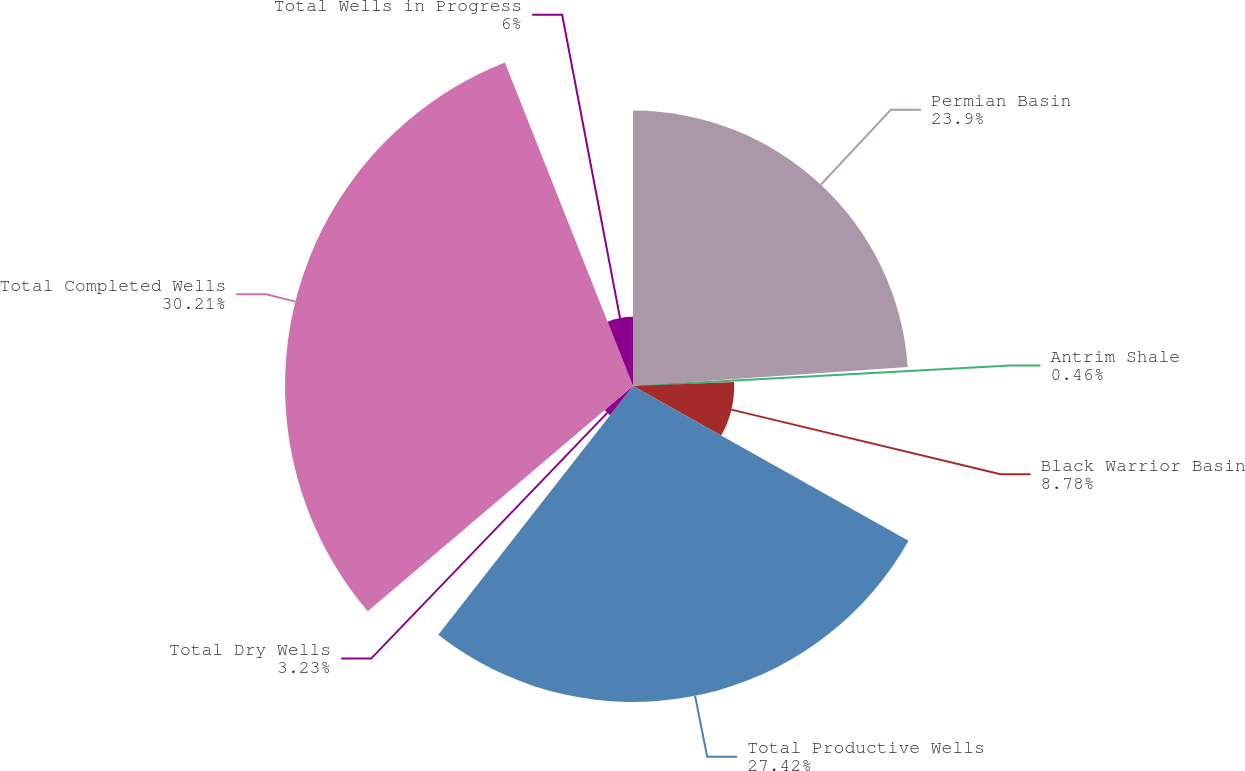<chart> <loc_0><loc_0><loc_500><loc_500><pie_chart><fcel>Permian Basin<fcel>Antrim Shale<fcel>Black Warrior Basin<fcel>Total Productive Wells<fcel>Total Dry Wells<fcel>Total Completed Wells<fcel>Total Wells in Progress<nl><fcel>23.9%<fcel>0.46%<fcel>8.78%<fcel>27.42%<fcel>3.23%<fcel>30.2%<fcel>6.0%<nl></chart> 